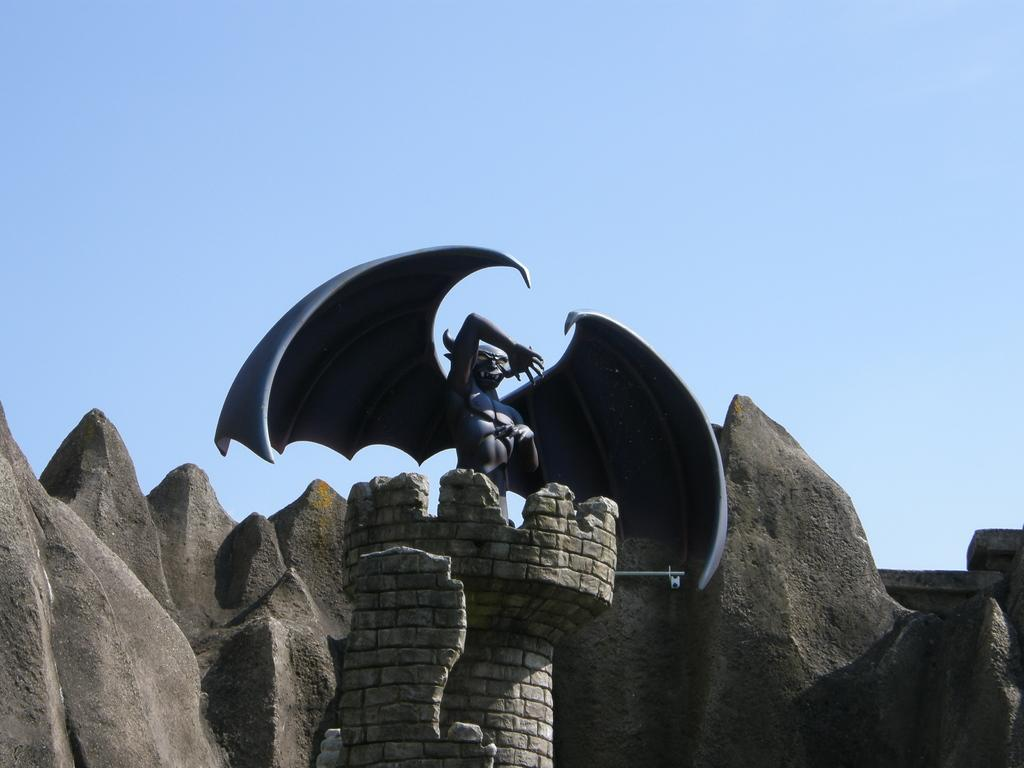What type of objects are present on the artificial rocks in the image? There is a Batman sculpture on the rocks in the image. What can be seen in the background of the image? The sky is visible in the background of the image. How does the leather increase the durability of the artificial rocks in the image? There is no leather mentioned in the image, and the artificial rocks do not have any leather components. 